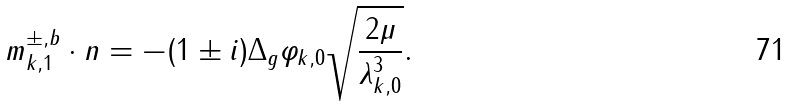<formula> <loc_0><loc_0><loc_500><loc_500>m _ { k , 1 } ^ { \pm , b } \cdot n = - ( 1 \pm i ) \Delta _ { g } \varphi _ { k , 0 } \sqrt { \frac { 2 \mu } { \lambda _ { k , 0 } ^ { 3 } } } .</formula> 